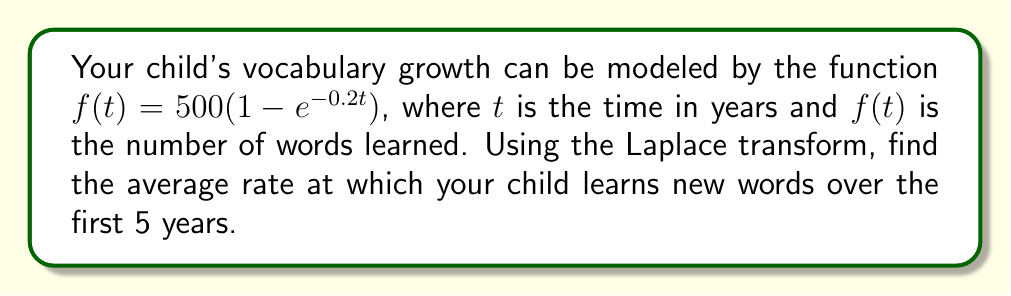Give your solution to this math problem. Let's approach this step-by-step:

1) First, we need to find the Laplace transform of $f(t)$. Let's call it $F(s)$.

   $F(s) = \mathcal{L}\{f(t)\} = \mathcal{L}\{500(1 - e^{-0.2t})\}$

2) Using linearity and the Laplace transform of exponential functions:

   $F(s) = 500 \cdot (\frac{1}{s} - \frac{1}{s+0.2})$

3) To find the average rate over 5 years, we need to use the Final Value Theorem:

   $\lim_{t \to 5} \frac{1}{5}\int_0^5 f(t)dt = \lim_{s \to 0} \frac{s}{5} \cdot \frac{F(s)}{s}$

4) Substituting our $F(s)$:

   $\lim_{s \to 0} \frac{s}{5} \cdot \frac{500 \cdot (\frac{1}{s} - \frac{1}{s+0.2})}{s}$

5) Simplifying:

   $\lim_{s \to 0} \frac{100}{s} - \frac{100}{s+0.2}$

6) As $s$ approaches 0, this becomes:

   $\frac{100}{0} - \frac{100}{0.2} = \infty - 500 = 500$

Therefore, the average rate at which your child learns new words over the first 5 years is 500 words per year.
Answer: 500 words per year 